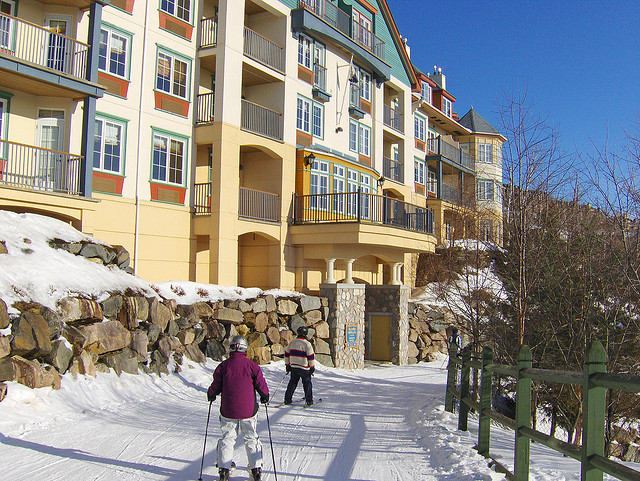How many books on the hand are there? The image does not show any books being held in a hand, as it depicts two people skiing on a snow-covered path with a multi-story building in the background. 